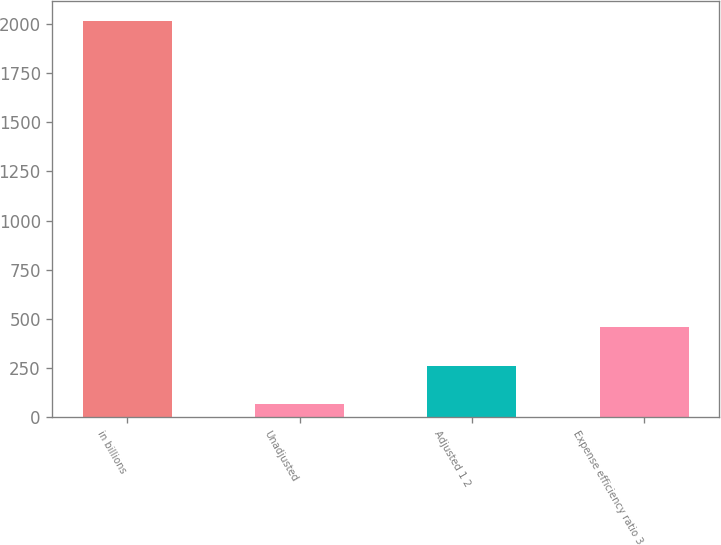<chart> <loc_0><loc_0><loc_500><loc_500><bar_chart><fcel>in billions<fcel>Unadjusted<fcel>Adjusted 1 2<fcel>Expense efficiency ratio 3<nl><fcel>2016<fcel>68.9<fcel>263.61<fcel>458.32<nl></chart> 